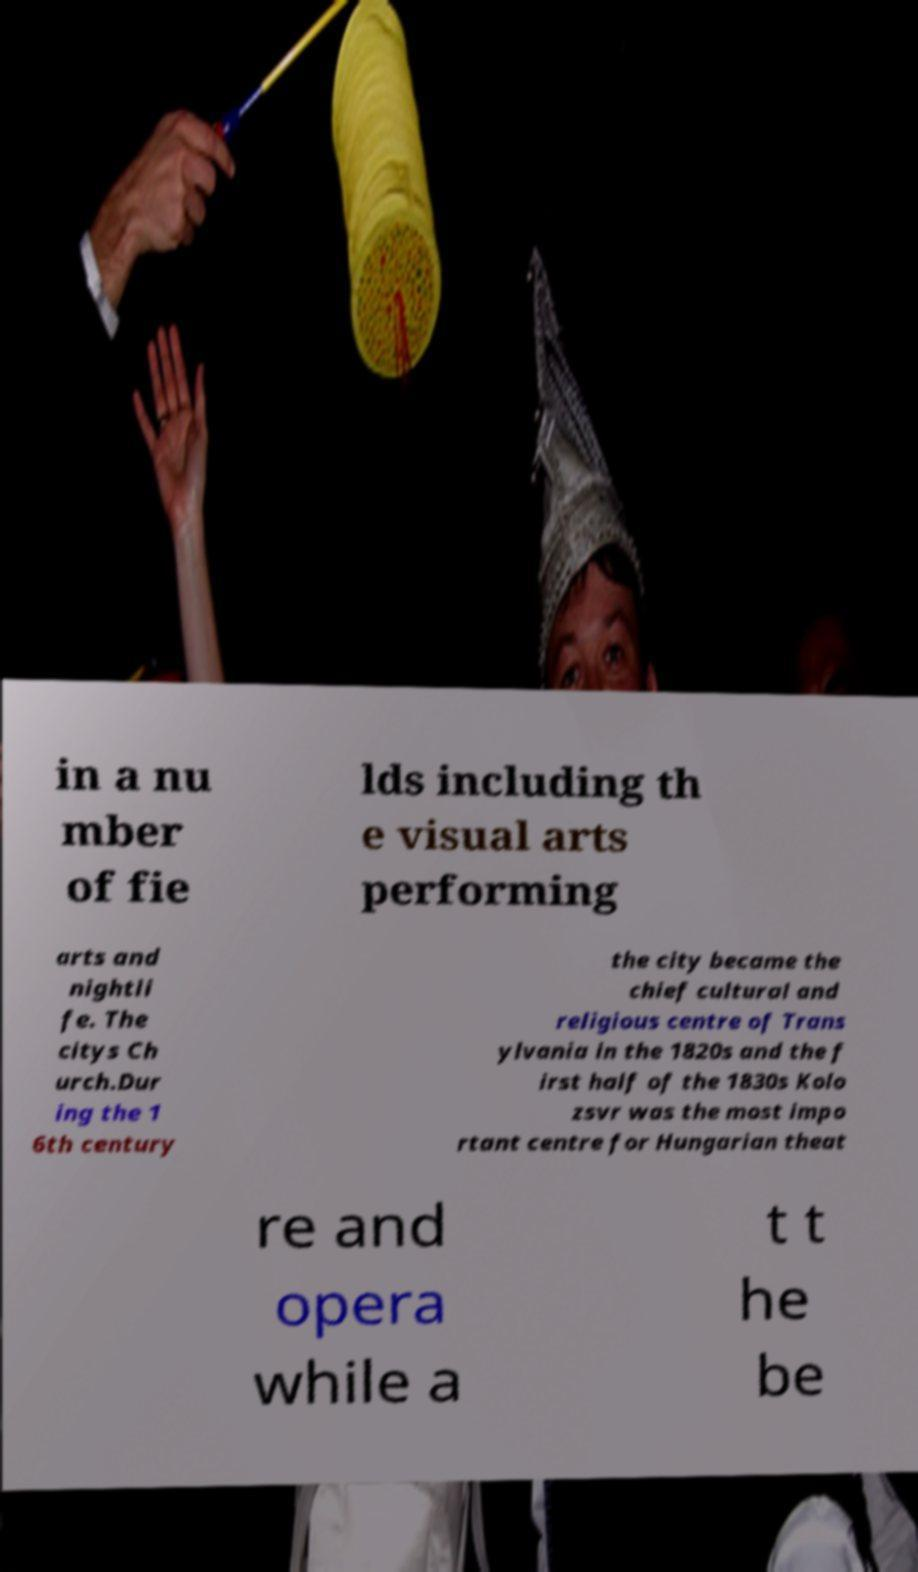Can you read and provide the text displayed in the image?This photo seems to have some interesting text. Can you extract and type it out for me? in a nu mber of fie lds including th e visual arts performing arts and nightli fe. The citys Ch urch.Dur ing the 1 6th century the city became the chief cultural and religious centre of Trans ylvania in the 1820s and the f irst half of the 1830s Kolo zsvr was the most impo rtant centre for Hungarian theat re and opera while a t t he be 